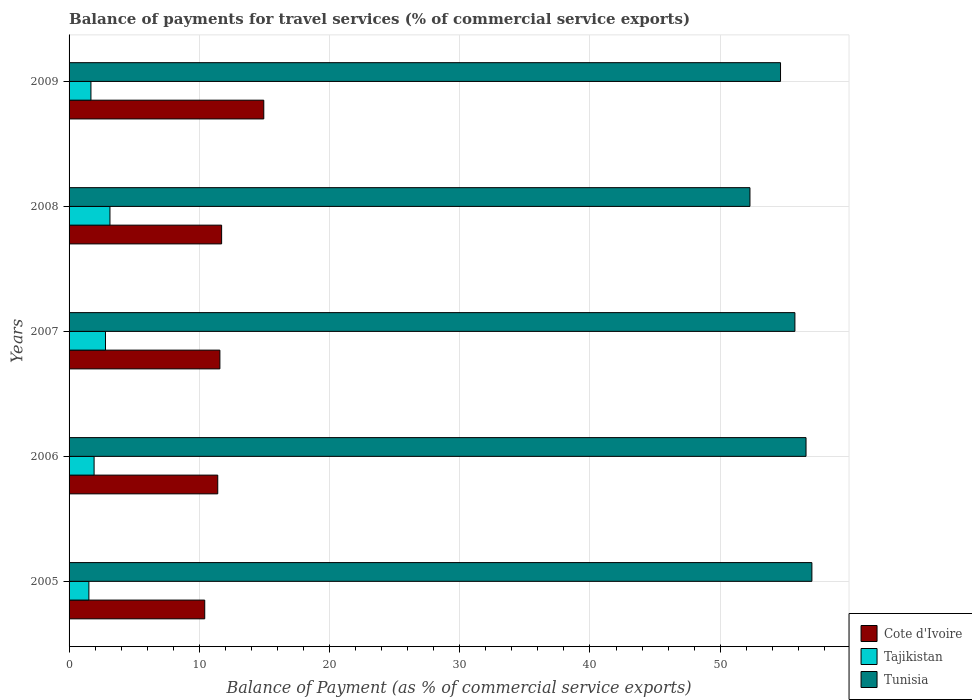How many bars are there on the 5th tick from the bottom?
Make the answer very short. 3. What is the label of the 3rd group of bars from the top?
Give a very brief answer. 2007. What is the balance of payments for travel services in Cote d'Ivoire in 2005?
Offer a very short reply. 10.42. Across all years, what is the maximum balance of payments for travel services in Tajikistan?
Ensure brevity in your answer.  3.14. Across all years, what is the minimum balance of payments for travel services in Tajikistan?
Offer a terse response. 1.52. What is the total balance of payments for travel services in Tunisia in the graph?
Make the answer very short. 276.29. What is the difference between the balance of payments for travel services in Cote d'Ivoire in 2008 and that in 2009?
Keep it short and to the point. -3.24. What is the difference between the balance of payments for travel services in Tunisia in 2006 and the balance of payments for travel services in Cote d'Ivoire in 2008?
Your answer should be compact. 44.88. What is the average balance of payments for travel services in Tajikistan per year?
Keep it short and to the point. 2.21. In the year 2008, what is the difference between the balance of payments for travel services in Tunisia and balance of payments for travel services in Tajikistan?
Offer a very short reply. 49.15. In how many years, is the balance of payments for travel services in Cote d'Ivoire greater than 50 %?
Your answer should be very brief. 0. What is the ratio of the balance of payments for travel services in Tunisia in 2007 to that in 2009?
Make the answer very short. 1.02. What is the difference between the highest and the second highest balance of payments for travel services in Tajikistan?
Provide a short and direct response. 0.34. What is the difference between the highest and the lowest balance of payments for travel services in Tajikistan?
Ensure brevity in your answer.  1.62. What does the 2nd bar from the top in 2007 represents?
Your response must be concise. Tajikistan. What does the 3rd bar from the bottom in 2008 represents?
Your response must be concise. Tunisia. How many bars are there?
Your answer should be very brief. 15. Are all the bars in the graph horizontal?
Give a very brief answer. Yes. How many years are there in the graph?
Make the answer very short. 5. What is the difference between two consecutive major ticks on the X-axis?
Provide a succinct answer. 10. Are the values on the major ticks of X-axis written in scientific E-notation?
Make the answer very short. No. Does the graph contain any zero values?
Make the answer very short. No. Does the graph contain grids?
Make the answer very short. Yes. Where does the legend appear in the graph?
Your answer should be compact. Bottom right. How many legend labels are there?
Give a very brief answer. 3. How are the legend labels stacked?
Provide a short and direct response. Vertical. What is the title of the graph?
Make the answer very short. Balance of payments for travel services (% of commercial service exports). What is the label or title of the X-axis?
Your answer should be very brief. Balance of Payment (as % of commercial service exports). What is the label or title of the Y-axis?
Your answer should be very brief. Years. What is the Balance of Payment (as % of commercial service exports) in Cote d'Ivoire in 2005?
Ensure brevity in your answer.  10.42. What is the Balance of Payment (as % of commercial service exports) of Tajikistan in 2005?
Your answer should be compact. 1.52. What is the Balance of Payment (as % of commercial service exports) in Tunisia in 2005?
Provide a succinct answer. 57.04. What is the Balance of Payment (as % of commercial service exports) of Cote d'Ivoire in 2006?
Your response must be concise. 11.42. What is the Balance of Payment (as % of commercial service exports) of Tajikistan in 2006?
Your response must be concise. 1.92. What is the Balance of Payment (as % of commercial service exports) in Tunisia in 2006?
Offer a terse response. 56.59. What is the Balance of Payment (as % of commercial service exports) of Cote d'Ivoire in 2007?
Your answer should be compact. 11.58. What is the Balance of Payment (as % of commercial service exports) of Tajikistan in 2007?
Ensure brevity in your answer.  2.8. What is the Balance of Payment (as % of commercial service exports) of Tunisia in 2007?
Make the answer very short. 55.74. What is the Balance of Payment (as % of commercial service exports) of Cote d'Ivoire in 2008?
Offer a very short reply. 11.72. What is the Balance of Payment (as % of commercial service exports) of Tajikistan in 2008?
Your response must be concise. 3.14. What is the Balance of Payment (as % of commercial service exports) in Tunisia in 2008?
Offer a very short reply. 52.29. What is the Balance of Payment (as % of commercial service exports) in Cote d'Ivoire in 2009?
Ensure brevity in your answer.  14.95. What is the Balance of Payment (as % of commercial service exports) in Tajikistan in 2009?
Offer a terse response. 1.68. What is the Balance of Payment (as % of commercial service exports) in Tunisia in 2009?
Your answer should be very brief. 54.63. Across all years, what is the maximum Balance of Payment (as % of commercial service exports) in Cote d'Ivoire?
Provide a short and direct response. 14.95. Across all years, what is the maximum Balance of Payment (as % of commercial service exports) of Tajikistan?
Provide a short and direct response. 3.14. Across all years, what is the maximum Balance of Payment (as % of commercial service exports) in Tunisia?
Make the answer very short. 57.04. Across all years, what is the minimum Balance of Payment (as % of commercial service exports) of Cote d'Ivoire?
Provide a short and direct response. 10.42. Across all years, what is the minimum Balance of Payment (as % of commercial service exports) of Tajikistan?
Your answer should be very brief. 1.52. Across all years, what is the minimum Balance of Payment (as % of commercial service exports) of Tunisia?
Your answer should be compact. 52.29. What is the total Balance of Payment (as % of commercial service exports) in Cote d'Ivoire in the graph?
Make the answer very short. 60.08. What is the total Balance of Payment (as % of commercial service exports) in Tajikistan in the graph?
Provide a short and direct response. 11.06. What is the total Balance of Payment (as % of commercial service exports) of Tunisia in the graph?
Give a very brief answer. 276.29. What is the difference between the Balance of Payment (as % of commercial service exports) of Cote d'Ivoire in 2005 and that in 2006?
Keep it short and to the point. -1. What is the difference between the Balance of Payment (as % of commercial service exports) in Tajikistan in 2005 and that in 2006?
Ensure brevity in your answer.  -0.4. What is the difference between the Balance of Payment (as % of commercial service exports) of Tunisia in 2005 and that in 2006?
Your response must be concise. 0.45. What is the difference between the Balance of Payment (as % of commercial service exports) of Cote d'Ivoire in 2005 and that in 2007?
Your answer should be compact. -1.16. What is the difference between the Balance of Payment (as % of commercial service exports) in Tajikistan in 2005 and that in 2007?
Provide a succinct answer. -1.27. What is the difference between the Balance of Payment (as % of commercial service exports) in Tunisia in 2005 and that in 2007?
Keep it short and to the point. 1.3. What is the difference between the Balance of Payment (as % of commercial service exports) in Cote d'Ivoire in 2005 and that in 2008?
Your response must be concise. -1.3. What is the difference between the Balance of Payment (as % of commercial service exports) of Tajikistan in 2005 and that in 2008?
Offer a terse response. -1.62. What is the difference between the Balance of Payment (as % of commercial service exports) of Tunisia in 2005 and that in 2008?
Your answer should be compact. 4.76. What is the difference between the Balance of Payment (as % of commercial service exports) of Cote d'Ivoire in 2005 and that in 2009?
Make the answer very short. -4.54. What is the difference between the Balance of Payment (as % of commercial service exports) of Tajikistan in 2005 and that in 2009?
Offer a terse response. -0.16. What is the difference between the Balance of Payment (as % of commercial service exports) of Tunisia in 2005 and that in 2009?
Ensure brevity in your answer.  2.41. What is the difference between the Balance of Payment (as % of commercial service exports) of Cote d'Ivoire in 2006 and that in 2007?
Your answer should be compact. -0.17. What is the difference between the Balance of Payment (as % of commercial service exports) in Tajikistan in 2006 and that in 2007?
Make the answer very short. -0.87. What is the difference between the Balance of Payment (as % of commercial service exports) of Tunisia in 2006 and that in 2007?
Your answer should be compact. 0.85. What is the difference between the Balance of Payment (as % of commercial service exports) of Cote d'Ivoire in 2006 and that in 2008?
Provide a succinct answer. -0.3. What is the difference between the Balance of Payment (as % of commercial service exports) of Tajikistan in 2006 and that in 2008?
Your response must be concise. -1.22. What is the difference between the Balance of Payment (as % of commercial service exports) of Tunisia in 2006 and that in 2008?
Make the answer very short. 4.31. What is the difference between the Balance of Payment (as % of commercial service exports) of Cote d'Ivoire in 2006 and that in 2009?
Your answer should be compact. -3.54. What is the difference between the Balance of Payment (as % of commercial service exports) in Tajikistan in 2006 and that in 2009?
Your answer should be compact. 0.24. What is the difference between the Balance of Payment (as % of commercial service exports) of Tunisia in 2006 and that in 2009?
Ensure brevity in your answer.  1.96. What is the difference between the Balance of Payment (as % of commercial service exports) of Cote d'Ivoire in 2007 and that in 2008?
Provide a succinct answer. -0.13. What is the difference between the Balance of Payment (as % of commercial service exports) in Tajikistan in 2007 and that in 2008?
Your response must be concise. -0.34. What is the difference between the Balance of Payment (as % of commercial service exports) of Tunisia in 2007 and that in 2008?
Provide a succinct answer. 3.45. What is the difference between the Balance of Payment (as % of commercial service exports) of Cote d'Ivoire in 2007 and that in 2009?
Offer a terse response. -3.37. What is the difference between the Balance of Payment (as % of commercial service exports) of Tajikistan in 2007 and that in 2009?
Ensure brevity in your answer.  1.12. What is the difference between the Balance of Payment (as % of commercial service exports) in Tunisia in 2007 and that in 2009?
Your answer should be compact. 1.1. What is the difference between the Balance of Payment (as % of commercial service exports) in Cote d'Ivoire in 2008 and that in 2009?
Offer a very short reply. -3.24. What is the difference between the Balance of Payment (as % of commercial service exports) in Tajikistan in 2008 and that in 2009?
Ensure brevity in your answer.  1.46. What is the difference between the Balance of Payment (as % of commercial service exports) of Tunisia in 2008 and that in 2009?
Give a very brief answer. -2.35. What is the difference between the Balance of Payment (as % of commercial service exports) of Cote d'Ivoire in 2005 and the Balance of Payment (as % of commercial service exports) of Tajikistan in 2006?
Make the answer very short. 8.5. What is the difference between the Balance of Payment (as % of commercial service exports) of Cote d'Ivoire in 2005 and the Balance of Payment (as % of commercial service exports) of Tunisia in 2006?
Your response must be concise. -46.18. What is the difference between the Balance of Payment (as % of commercial service exports) of Tajikistan in 2005 and the Balance of Payment (as % of commercial service exports) of Tunisia in 2006?
Provide a short and direct response. -55.07. What is the difference between the Balance of Payment (as % of commercial service exports) in Cote d'Ivoire in 2005 and the Balance of Payment (as % of commercial service exports) in Tajikistan in 2007?
Provide a succinct answer. 7.62. What is the difference between the Balance of Payment (as % of commercial service exports) in Cote d'Ivoire in 2005 and the Balance of Payment (as % of commercial service exports) in Tunisia in 2007?
Keep it short and to the point. -45.32. What is the difference between the Balance of Payment (as % of commercial service exports) in Tajikistan in 2005 and the Balance of Payment (as % of commercial service exports) in Tunisia in 2007?
Keep it short and to the point. -54.22. What is the difference between the Balance of Payment (as % of commercial service exports) in Cote d'Ivoire in 2005 and the Balance of Payment (as % of commercial service exports) in Tajikistan in 2008?
Provide a succinct answer. 7.28. What is the difference between the Balance of Payment (as % of commercial service exports) of Cote d'Ivoire in 2005 and the Balance of Payment (as % of commercial service exports) of Tunisia in 2008?
Provide a short and direct response. -41.87. What is the difference between the Balance of Payment (as % of commercial service exports) of Tajikistan in 2005 and the Balance of Payment (as % of commercial service exports) of Tunisia in 2008?
Keep it short and to the point. -50.76. What is the difference between the Balance of Payment (as % of commercial service exports) in Cote d'Ivoire in 2005 and the Balance of Payment (as % of commercial service exports) in Tajikistan in 2009?
Keep it short and to the point. 8.74. What is the difference between the Balance of Payment (as % of commercial service exports) of Cote d'Ivoire in 2005 and the Balance of Payment (as % of commercial service exports) of Tunisia in 2009?
Your response must be concise. -44.22. What is the difference between the Balance of Payment (as % of commercial service exports) of Tajikistan in 2005 and the Balance of Payment (as % of commercial service exports) of Tunisia in 2009?
Offer a terse response. -53.11. What is the difference between the Balance of Payment (as % of commercial service exports) in Cote d'Ivoire in 2006 and the Balance of Payment (as % of commercial service exports) in Tajikistan in 2007?
Offer a very short reply. 8.62. What is the difference between the Balance of Payment (as % of commercial service exports) in Cote d'Ivoire in 2006 and the Balance of Payment (as % of commercial service exports) in Tunisia in 2007?
Your answer should be very brief. -44.32. What is the difference between the Balance of Payment (as % of commercial service exports) in Tajikistan in 2006 and the Balance of Payment (as % of commercial service exports) in Tunisia in 2007?
Keep it short and to the point. -53.82. What is the difference between the Balance of Payment (as % of commercial service exports) of Cote d'Ivoire in 2006 and the Balance of Payment (as % of commercial service exports) of Tajikistan in 2008?
Ensure brevity in your answer.  8.28. What is the difference between the Balance of Payment (as % of commercial service exports) of Cote d'Ivoire in 2006 and the Balance of Payment (as % of commercial service exports) of Tunisia in 2008?
Your answer should be compact. -40.87. What is the difference between the Balance of Payment (as % of commercial service exports) in Tajikistan in 2006 and the Balance of Payment (as % of commercial service exports) in Tunisia in 2008?
Your answer should be very brief. -50.36. What is the difference between the Balance of Payment (as % of commercial service exports) in Cote d'Ivoire in 2006 and the Balance of Payment (as % of commercial service exports) in Tajikistan in 2009?
Give a very brief answer. 9.74. What is the difference between the Balance of Payment (as % of commercial service exports) in Cote d'Ivoire in 2006 and the Balance of Payment (as % of commercial service exports) in Tunisia in 2009?
Offer a very short reply. -43.22. What is the difference between the Balance of Payment (as % of commercial service exports) of Tajikistan in 2006 and the Balance of Payment (as % of commercial service exports) of Tunisia in 2009?
Provide a short and direct response. -52.71. What is the difference between the Balance of Payment (as % of commercial service exports) of Cote d'Ivoire in 2007 and the Balance of Payment (as % of commercial service exports) of Tajikistan in 2008?
Ensure brevity in your answer.  8.44. What is the difference between the Balance of Payment (as % of commercial service exports) of Cote d'Ivoire in 2007 and the Balance of Payment (as % of commercial service exports) of Tunisia in 2008?
Your response must be concise. -40.7. What is the difference between the Balance of Payment (as % of commercial service exports) in Tajikistan in 2007 and the Balance of Payment (as % of commercial service exports) in Tunisia in 2008?
Offer a very short reply. -49.49. What is the difference between the Balance of Payment (as % of commercial service exports) of Cote d'Ivoire in 2007 and the Balance of Payment (as % of commercial service exports) of Tajikistan in 2009?
Provide a succinct answer. 9.9. What is the difference between the Balance of Payment (as % of commercial service exports) in Cote d'Ivoire in 2007 and the Balance of Payment (as % of commercial service exports) in Tunisia in 2009?
Make the answer very short. -43.05. What is the difference between the Balance of Payment (as % of commercial service exports) of Tajikistan in 2007 and the Balance of Payment (as % of commercial service exports) of Tunisia in 2009?
Make the answer very short. -51.84. What is the difference between the Balance of Payment (as % of commercial service exports) in Cote d'Ivoire in 2008 and the Balance of Payment (as % of commercial service exports) in Tajikistan in 2009?
Ensure brevity in your answer.  10.04. What is the difference between the Balance of Payment (as % of commercial service exports) in Cote d'Ivoire in 2008 and the Balance of Payment (as % of commercial service exports) in Tunisia in 2009?
Your answer should be compact. -42.92. What is the difference between the Balance of Payment (as % of commercial service exports) of Tajikistan in 2008 and the Balance of Payment (as % of commercial service exports) of Tunisia in 2009?
Offer a very short reply. -51.5. What is the average Balance of Payment (as % of commercial service exports) in Cote d'Ivoire per year?
Offer a very short reply. 12.02. What is the average Balance of Payment (as % of commercial service exports) in Tajikistan per year?
Give a very brief answer. 2.21. What is the average Balance of Payment (as % of commercial service exports) of Tunisia per year?
Provide a succinct answer. 55.26. In the year 2005, what is the difference between the Balance of Payment (as % of commercial service exports) in Cote d'Ivoire and Balance of Payment (as % of commercial service exports) in Tajikistan?
Make the answer very short. 8.9. In the year 2005, what is the difference between the Balance of Payment (as % of commercial service exports) of Cote d'Ivoire and Balance of Payment (as % of commercial service exports) of Tunisia?
Make the answer very short. -46.63. In the year 2005, what is the difference between the Balance of Payment (as % of commercial service exports) of Tajikistan and Balance of Payment (as % of commercial service exports) of Tunisia?
Your answer should be compact. -55.52. In the year 2006, what is the difference between the Balance of Payment (as % of commercial service exports) in Cote d'Ivoire and Balance of Payment (as % of commercial service exports) in Tajikistan?
Your answer should be very brief. 9.5. In the year 2006, what is the difference between the Balance of Payment (as % of commercial service exports) of Cote d'Ivoire and Balance of Payment (as % of commercial service exports) of Tunisia?
Give a very brief answer. -45.18. In the year 2006, what is the difference between the Balance of Payment (as % of commercial service exports) in Tajikistan and Balance of Payment (as % of commercial service exports) in Tunisia?
Make the answer very short. -54.67. In the year 2007, what is the difference between the Balance of Payment (as % of commercial service exports) of Cote d'Ivoire and Balance of Payment (as % of commercial service exports) of Tajikistan?
Offer a terse response. 8.79. In the year 2007, what is the difference between the Balance of Payment (as % of commercial service exports) in Cote d'Ivoire and Balance of Payment (as % of commercial service exports) in Tunisia?
Provide a short and direct response. -44.16. In the year 2007, what is the difference between the Balance of Payment (as % of commercial service exports) of Tajikistan and Balance of Payment (as % of commercial service exports) of Tunisia?
Keep it short and to the point. -52.94. In the year 2008, what is the difference between the Balance of Payment (as % of commercial service exports) in Cote d'Ivoire and Balance of Payment (as % of commercial service exports) in Tajikistan?
Offer a terse response. 8.58. In the year 2008, what is the difference between the Balance of Payment (as % of commercial service exports) in Cote d'Ivoire and Balance of Payment (as % of commercial service exports) in Tunisia?
Ensure brevity in your answer.  -40.57. In the year 2008, what is the difference between the Balance of Payment (as % of commercial service exports) in Tajikistan and Balance of Payment (as % of commercial service exports) in Tunisia?
Your response must be concise. -49.15. In the year 2009, what is the difference between the Balance of Payment (as % of commercial service exports) of Cote d'Ivoire and Balance of Payment (as % of commercial service exports) of Tajikistan?
Provide a short and direct response. 13.27. In the year 2009, what is the difference between the Balance of Payment (as % of commercial service exports) in Cote d'Ivoire and Balance of Payment (as % of commercial service exports) in Tunisia?
Give a very brief answer. -39.68. In the year 2009, what is the difference between the Balance of Payment (as % of commercial service exports) of Tajikistan and Balance of Payment (as % of commercial service exports) of Tunisia?
Ensure brevity in your answer.  -52.96. What is the ratio of the Balance of Payment (as % of commercial service exports) of Cote d'Ivoire in 2005 to that in 2006?
Your response must be concise. 0.91. What is the ratio of the Balance of Payment (as % of commercial service exports) in Tajikistan in 2005 to that in 2006?
Offer a terse response. 0.79. What is the ratio of the Balance of Payment (as % of commercial service exports) of Cote d'Ivoire in 2005 to that in 2007?
Offer a terse response. 0.9. What is the ratio of the Balance of Payment (as % of commercial service exports) of Tajikistan in 2005 to that in 2007?
Give a very brief answer. 0.54. What is the ratio of the Balance of Payment (as % of commercial service exports) in Tunisia in 2005 to that in 2007?
Your answer should be compact. 1.02. What is the ratio of the Balance of Payment (as % of commercial service exports) in Cote d'Ivoire in 2005 to that in 2008?
Your response must be concise. 0.89. What is the ratio of the Balance of Payment (as % of commercial service exports) in Tajikistan in 2005 to that in 2008?
Keep it short and to the point. 0.48. What is the ratio of the Balance of Payment (as % of commercial service exports) of Tunisia in 2005 to that in 2008?
Provide a succinct answer. 1.09. What is the ratio of the Balance of Payment (as % of commercial service exports) of Cote d'Ivoire in 2005 to that in 2009?
Offer a very short reply. 0.7. What is the ratio of the Balance of Payment (as % of commercial service exports) in Tajikistan in 2005 to that in 2009?
Provide a short and direct response. 0.91. What is the ratio of the Balance of Payment (as % of commercial service exports) in Tunisia in 2005 to that in 2009?
Keep it short and to the point. 1.04. What is the ratio of the Balance of Payment (as % of commercial service exports) in Cote d'Ivoire in 2006 to that in 2007?
Keep it short and to the point. 0.99. What is the ratio of the Balance of Payment (as % of commercial service exports) in Tajikistan in 2006 to that in 2007?
Your answer should be compact. 0.69. What is the ratio of the Balance of Payment (as % of commercial service exports) of Tunisia in 2006 to that in 2007?
Provide a short and direct response. 1.02. What is the ratio of the Balance of Payment (as % of commercial service exports) in Cote d'Ivoire in 2006 to that in 2008?
Your response must be concise. 0.97. What is the ratio of the Balance of Payment (as % of commercial service exports) of Tajikistan in 2006 to that in 2008?
Your answer should be very brief. 0.61. What is the ratio of the Balance of Payment (as % of commercial service exports) in Tunisia in 2006 to that in 2008?
Provide a short and direct response. 1.08. What is the ratio of the Balance of Payment (as % of commercial service exports) of Cote d'Ivoire in 2006 to that in 2009?
Keep it short and to the point. 0.76. What is the ratio of the Balance of Payment (as % of commercial service exports) of Tajikistan in 2006 to that in 2009?
Make the answer very short. 1.14. What is the ratio of the Balance of Payment (as % of commercial service exports) in Tunisia in 2006 to that in 2009?
Provide a succinct answer. 1.04. What is the ratio of the Balance of Payment (as % of commercial service exports) of Cote d'Ivoire in 2007 to that in 2008?
Your answer should be very brief. 0.99. What is the ratio of the Balance of Payment (as % of commercial service exports) in Tajikistan in 2007 to that in 2008?
Keep it short and to the point. 0.89. What is the ratio of the Balance of Payment (as % of commercial service exports) of Tunisia in 2007 to that in 2008?
Offer a very short reply. 1.07. What is the ratio of the Balance of Payment (as % of commercial service exports) in Cote d'Ivoire in 2007 to that in 2009?
Ensure brevity in your answer.  0.77. What is the ratio of the Balance of Payment (as % of commercial service exports) in Tajikistan in 2007 to that in 2009?
Your response must be concise. 1.66. What is the ratio of the Balance of Payment (as % of commercial service exports) of Tunisia in 2007 to that in 2009?
Keep it short and to the point. 1.02. What is the ratio of the Balance of Payment (as % of commercial service exports) in Cote d'Ivoire in 2008 to that in 2009?
Provide a succinct answer. 0.78. What is the ratio of the Balance of Payment (as % of commercial service exports) in Tajikistan in 2008 to that in 2009?
Offer a very short reply. 1.87. What is the difference between the highest and the second highest Balance of Payment (as % of commercial service exports) in Cote d'Ivoire?
Make the answer very short. 3.24. What is the difference between the highest and the second highest Balance of Payment (as % of commercial service exports) of Tajikistan?
Ensure brevity in your answer.  0.34. What is the difference between the highest and the second highest Balance of Payment (as % of commercial service exports) of Tunisia?
Keep it short and to the point. 0.45. What is the difference between the highest and the lowest Balance of Payment (as % of commercial service exports) of Cote d'Ivoire?
Make the answer very short. 4.54. What is the difference between the highest and the lowest Balance of Payment (as % of commercial service exports) in Tajikistan?
Offer a terse response. 1.62. What is the difference between the highest and the lowest Balance of Payment (as % of commercial service exports) in Tunisia?
Offer a terse response. 4.76. 